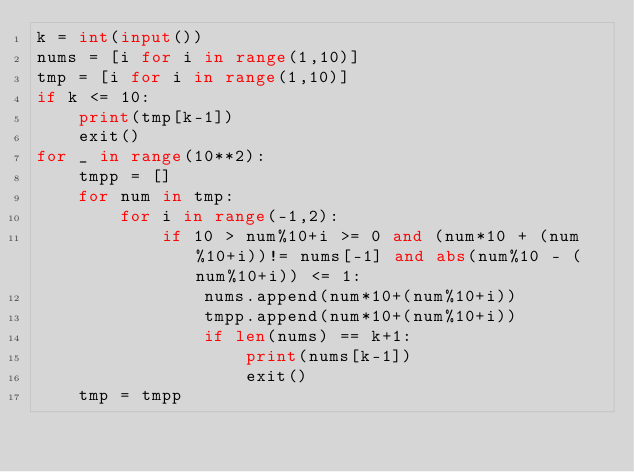<code> <loc_0><loc_0><loc_500><loc_500><_Python_>k = int(input())
nums = [i for i in range(1,10)]
tmp = [i for i in range(1,10)]
if k <= 10:
    print(tmp[k-1])
    exit()
for _ in range(10**2):
    tmpp = []
    for num in tmp:
        for i in range(-1,2):
            if 10 > num%10+i >= 0 and (num*10 + (num%10+i))!= nums[-1] and abs(num%10 - (num%10+i)) <= 1:
                nums.append(num*10+(num%10+i))
                tmpp.append(num*10+(num%10+i))
                if len(nums) == k+1:
                    print(nums[k-1])
                    exit()
    tmp = tmpp</code> 